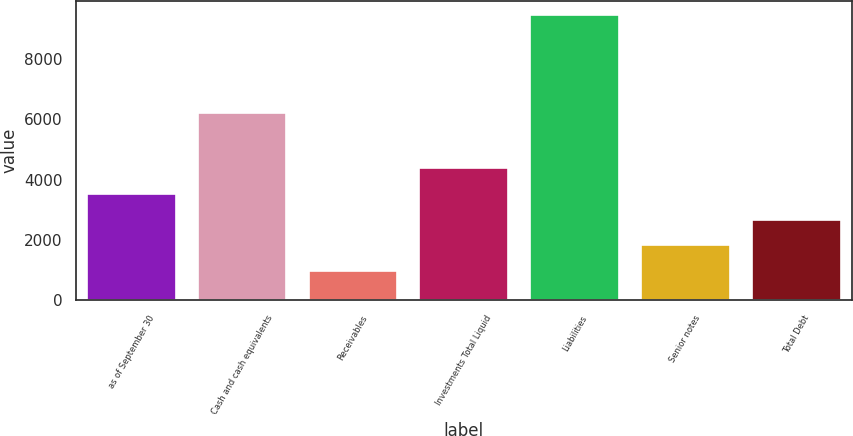Convert chart to OTSL. <chart><loc_0><loc_0><loc_500><loc_500><bar_chart><fcel>as of September 30<fcel>Cash and cash equivalents<fcel>Receivables<fcel>Investments Total Liquid<fcel>Liabilities<fcel>Senior notes<fcel>Total Debt<nl><fcel>3522.14<fcel>6186<fcel>982.1<fcel>4368.82<fcel>9448.9<fcel>1828.78<fcel>2675.46<nl></chart> 